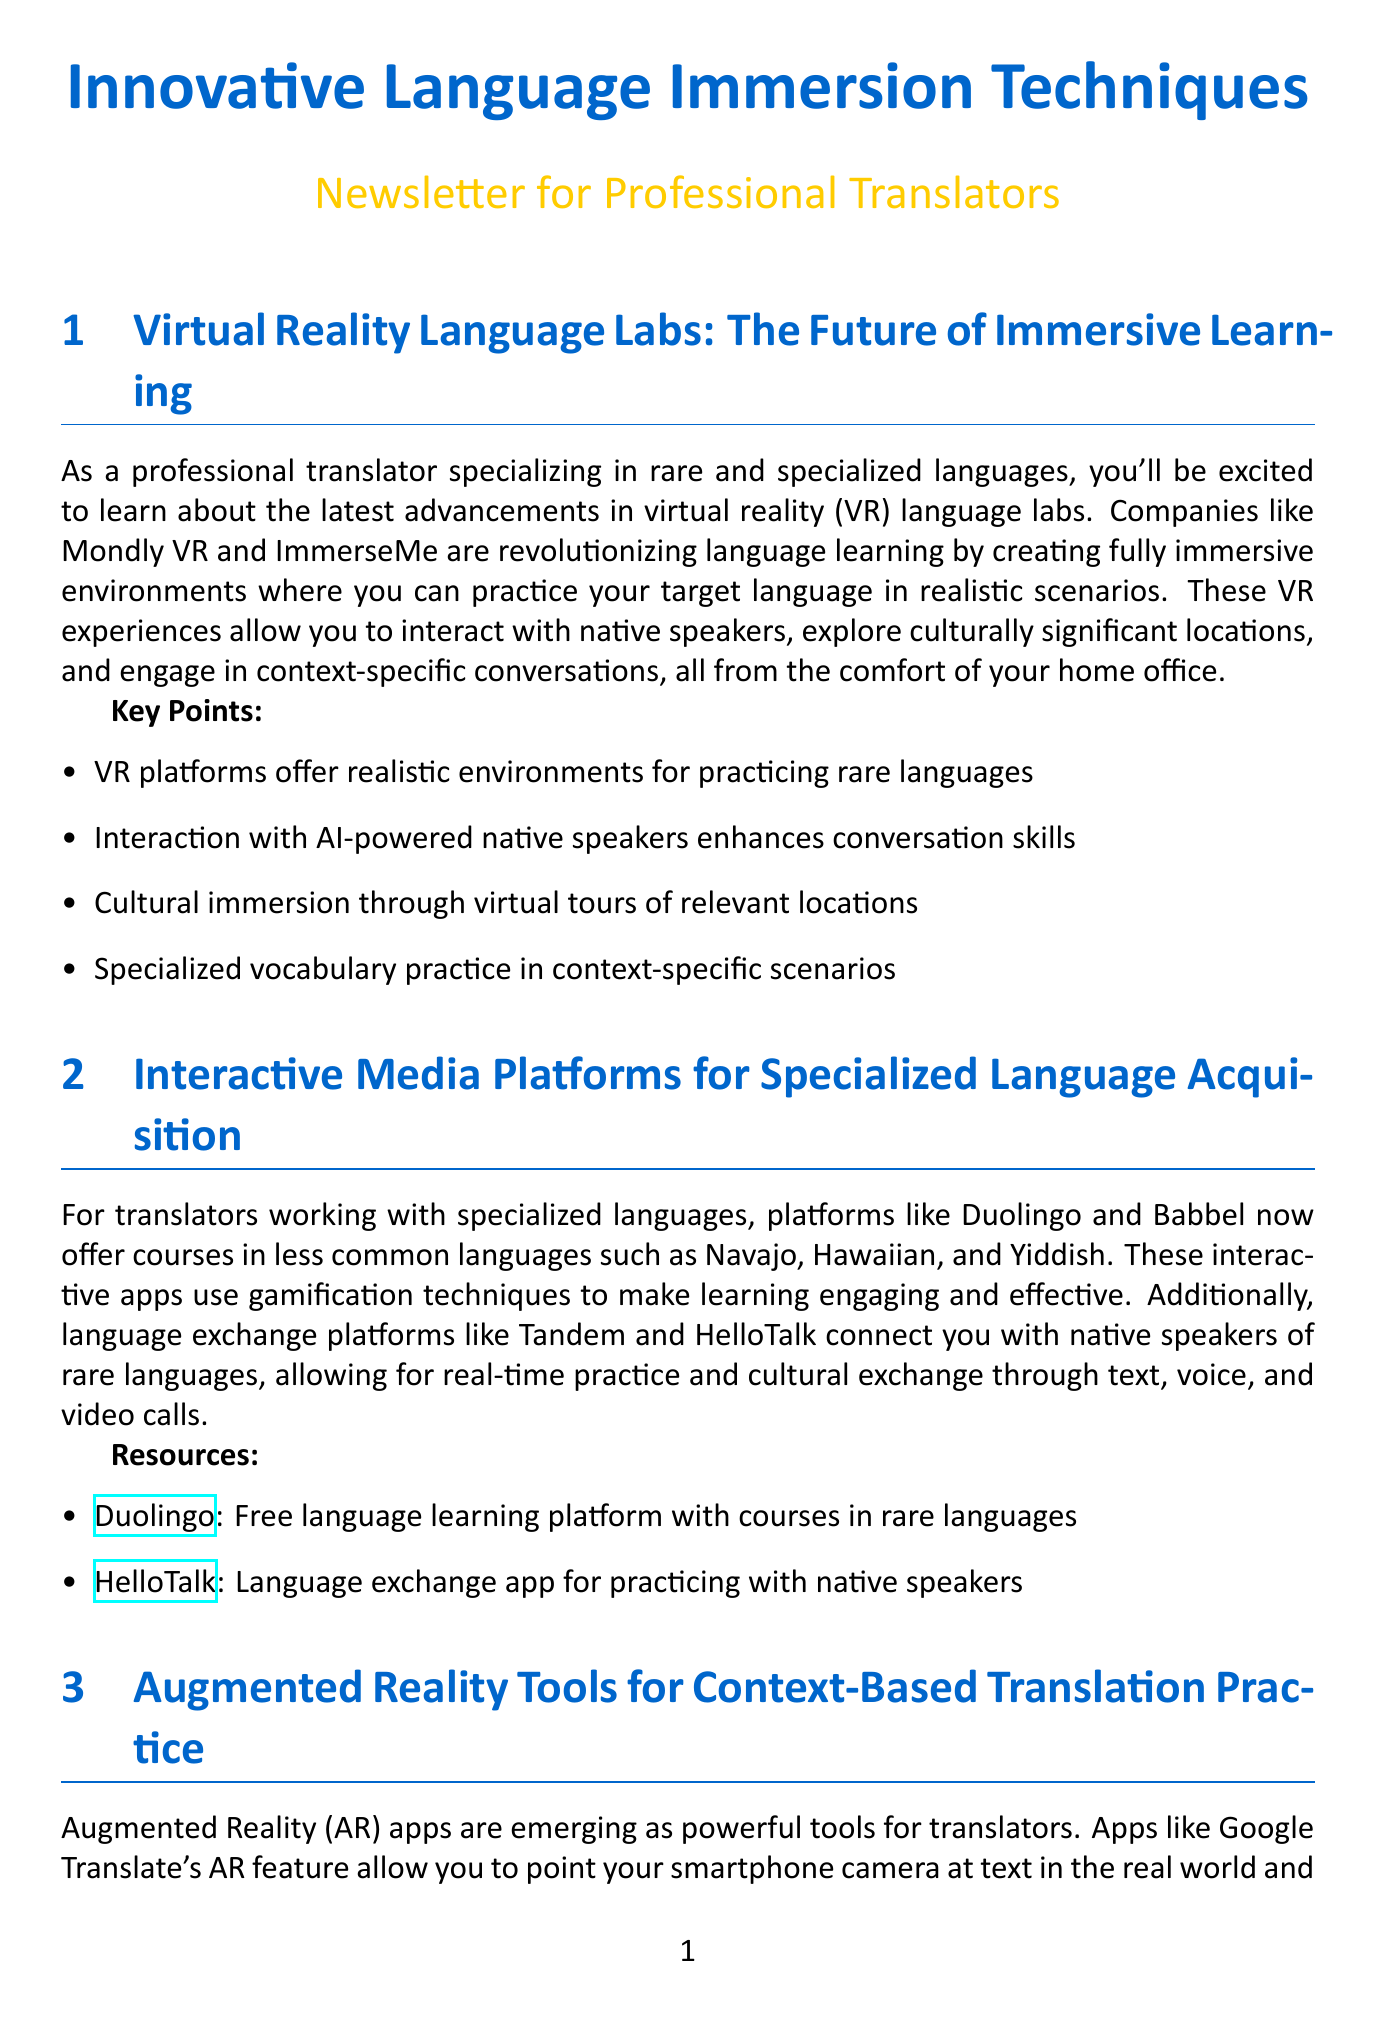What are VR platforms used for? VR platforms are used for practicing rare languages in realistic environments.
Answer: Practicing rare languages Which companies are mentioned for VR language labs? The companies mentioned for VR language labs are Mondly VR and ImmerseMe.
Answer: Mondly VR and ImmerseMe What type of languages do Duolingo and Babbel focus on? Duolingo and Babbel offer courses in less common languages, including Navajo, Hawaiian, and Yiddish.
Answer: Less common languages What is a benefit of Augmented Reality apps for translators? A benefit of Augmented Reality apps is real-time translation of specialized texts in context.
Answer: Real-time translation Name one AI-powered language partner platform. One AI-powered language partner platform mentioned is Replika.
Answer: Replika What kind of resources does Radio Lingua Network offer? Radio Lingua Network offers podcasts in less commonly taught languages.
Answer: Podcasts in less commonly taught languages How can specialized vocabulary be practiced according to the newsletter? Specialized vocabulary can be practiced in context-specific scenarios.
Answer: Context-specific scenarios What enhances conversation skills in VR language labs? Interaction with AI-powered native speakers enhances conversation skills.
Answer: Interaction with AI-powered native speakers 